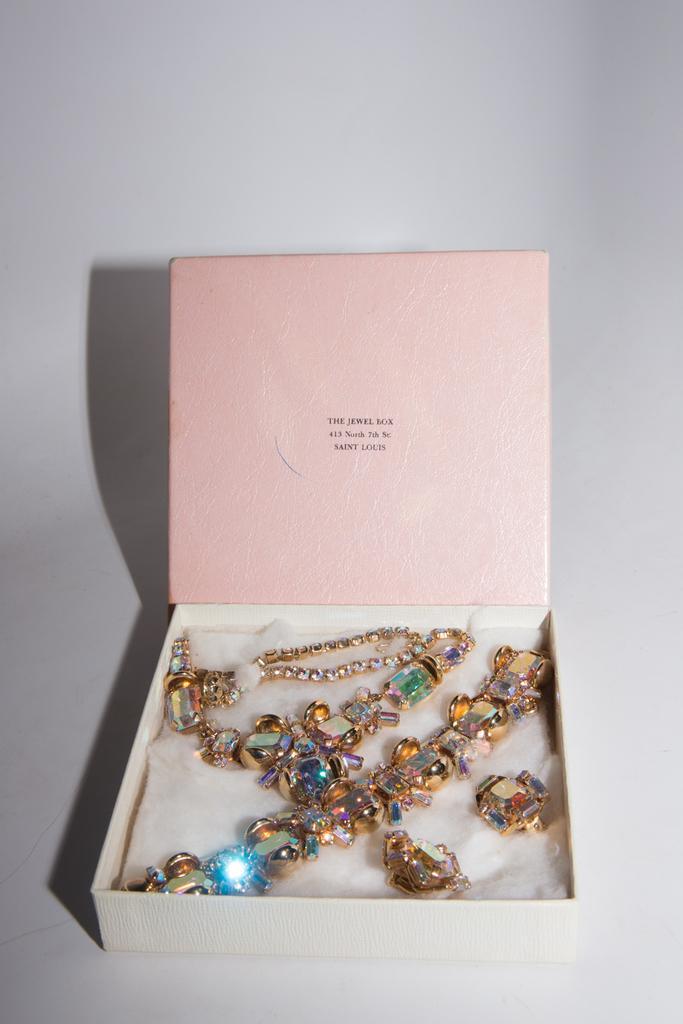Could you give a brief overview of what you see in this image? In the middle of the image we can see a box, in the box we can find few ornaments. 